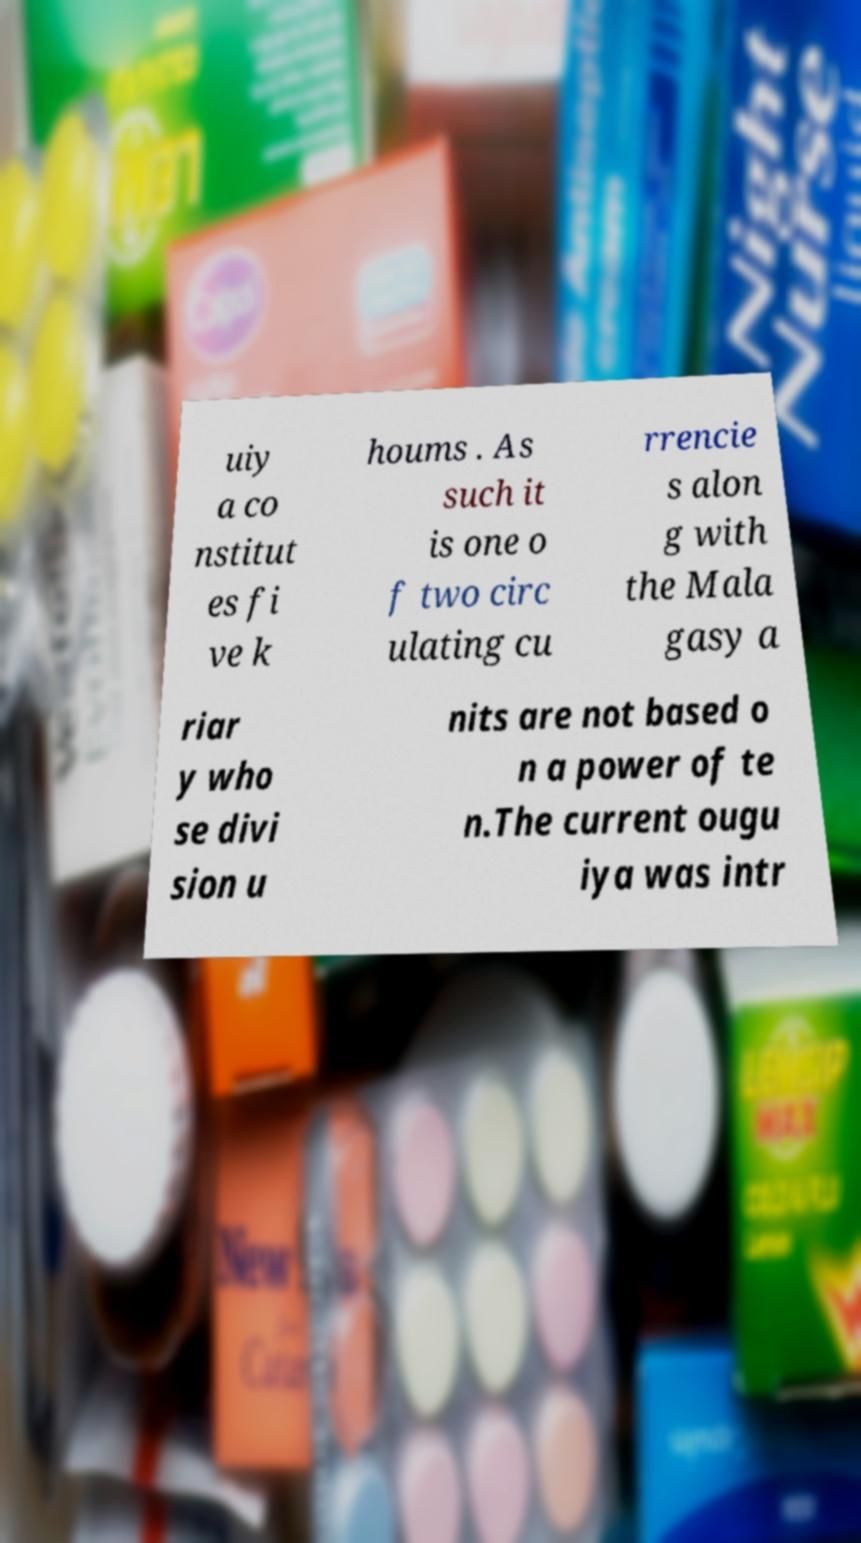What messages or text are displayed in this image? I need them in a readable, typed format. uiy a co nstitut es fi ve k houms . As such it is one o f two circ ulating cu rrencie s alon g with the Mala gasy a riar y who se divi sion u nits are not based o n a power of te n.The current ougu iya was intr 